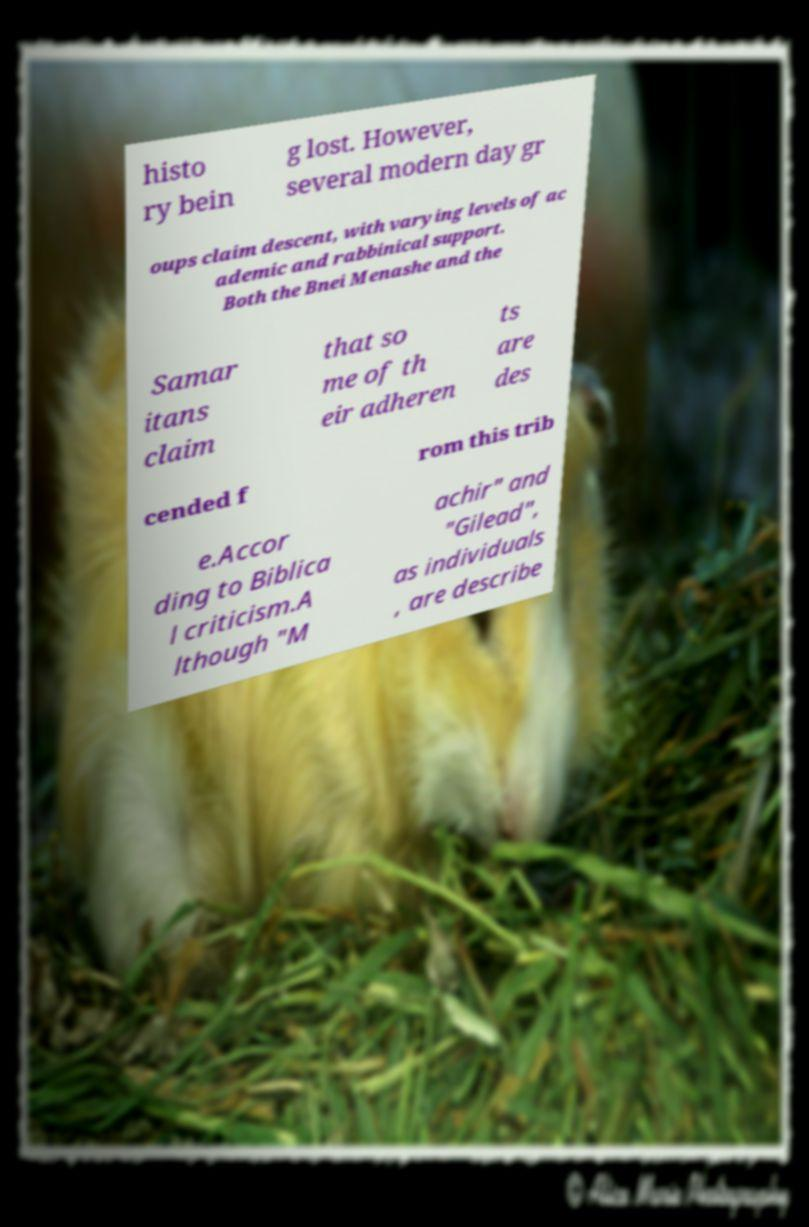Could you extract and type out the text from this image? histo ry bein g lost. However, several modern day gr oups claim descent, with varying levels of ac ademic and rabbinical support. Both the Bnei Menashe and the Samar itans claim that so me of th eir adheren ts are des cended f rom this trib e.Accor ding to Biblica l criticism.A lthough "M achir" and "Gilead", as individuals , are describe 